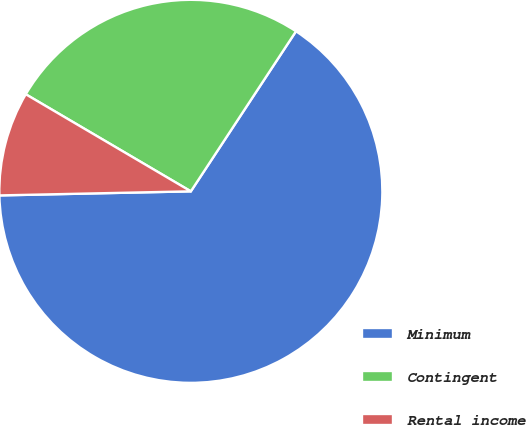<chart> <loc_0><loc_0><loc_500><loc_500><pie_chart><fcel>Minimum<fcel>Contingent<fcel>Rental income<nl><fcel>65.41%<fcel>25.79%<fcel>8.8%<nl></chart> 